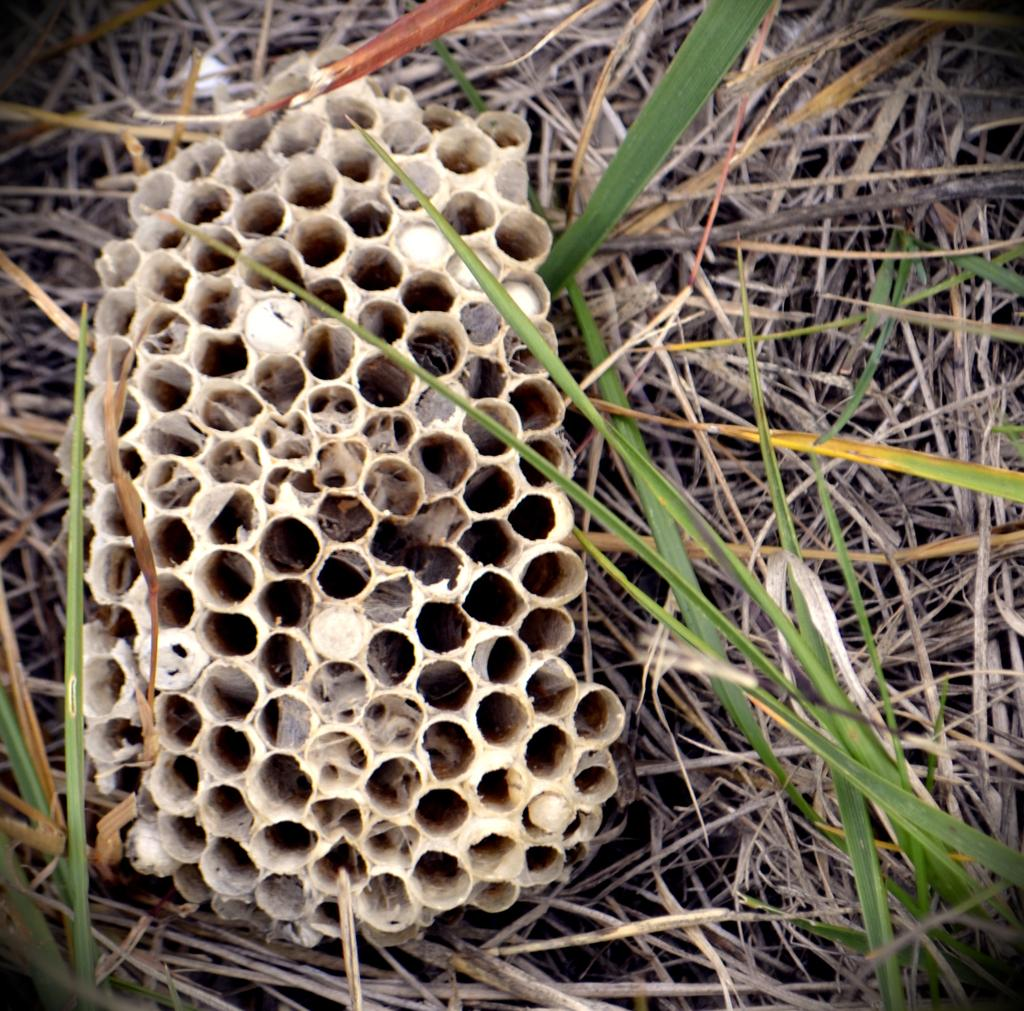What is the main subject of the image? The main subject of the image is a honeycomb. What can be seen surrounding the honeycomb? There are grasses around the honeycomb. Can you see a giraffe observing the honeycomb in the image? There is no giraffe present in the image, and therefore no such observation can be made. 